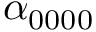<formula> <loc_0><loc_0><loc_500><loc_500>\alpha _ { 0 0 0 0 }</formula> 